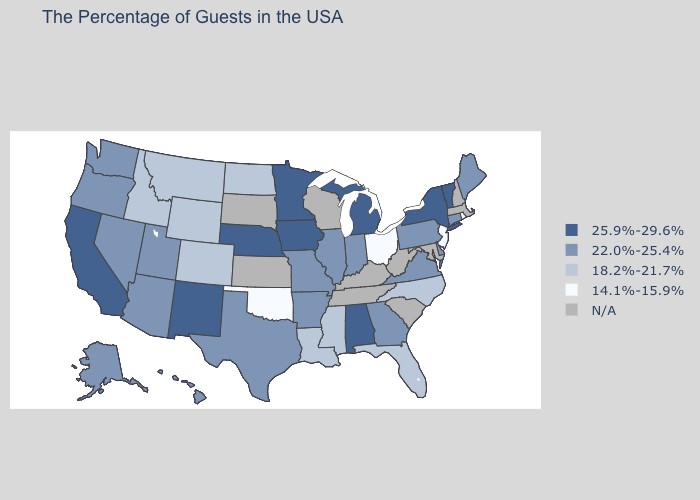What is the value of Michigan?
Short answer required. 25.9%-29.6%. What is the value of Massachusetts?
Be succinct. N/A. What is the highest value in the USA?
Concise answer only. 25.9%-29.6%. Does Rhode Island have the lowest value in the Northeast?
Answer briefly. Yes. Name the states that have a value in the range 14.1%-15.9%?
Answer briefly. Rhode Island, New Jersey, Ohio, Oklahoma. Among the states that border South Carolina , does Georgia have the lowest value?
Keep it brief. No. What is the lowest value in states that border Arkansas?
Quick response, please. 14.1%-15.9%. What is the lowest value in the USA?
Concise answer only. 14.1%-15.9%. What is the value of Georgia?
Answer briefly. 22.0%-25.4%. Which states have the lowest value in the USA?
Concise answer only. Rhode Island, New Jersey, Ohio, Oklahoma. Name the states that have a value in the range N/A?
Quick response, please. Massachusetts, New Hampshire, Maryland, South Carolina, West Virginia, Kentucky, Tennessee, Wisconsin, Kansas, South Dakota. Name the states that have a value in the range 22.0%-25.4%?
Keep it brief. Maine, Connecticut, Delaware, Pennsylvania, Virginia, Georgia, Indiana, Illinois, Missouri, Arkansas, Texas, Utah, Arizona, Nevada, Washington, Oregon, Alaska, Hawaii. What is the value of Montana?
Keep it brief. 18.2%-21.7%. What is the value of Wisconsin?
Quick response, please. N/A. What is the lowest value in the USA?
Give a very brief answer. 14.1%-15.9%. 